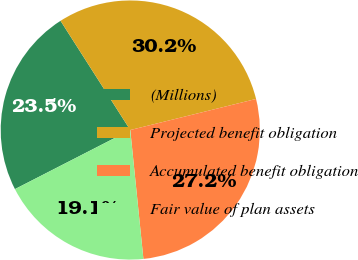Convert chart to OTSL. <chart><loc_0><loc_0><loc_500><loc_500><pie_chart><fcel>(Millions)<fcel>Projected benefit obligation<fcel>Accumulated benefit obligation<fcel>Fair value of plan assets<nl><fcel>23.49%<fcel>30.19%<fcel>27.24%<fcel>19.08%<nl></chart> 